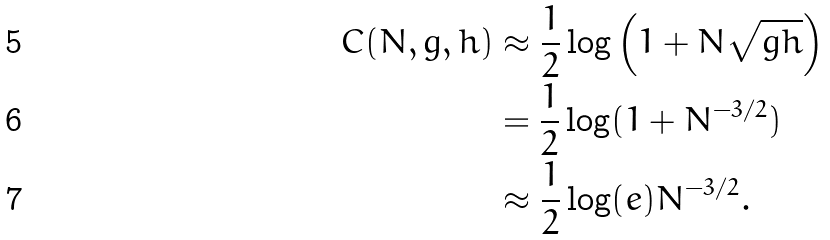<formula> <loc_0><loc_0><loc_500><loc_500>C ( N , g , h ) & \approx \frac { 1 } { 2 } \log \left ( 1 + N { \sqrt { g h } } \right ) \\ & = \frac { 1 } { 2 } \log ( 1 + N ^ { - 3 / 2 } ) \\ & \approx \frac { 1 } { 2 } \log ( e ) N ^ { - 3 / 2 } .</formula> 